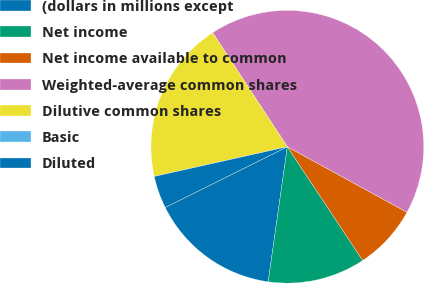Convert chart to OTSL. <chart><loc_0><loc_0><loc_500><loc_500><pie_chart><fcel>(dollars in millions except<fcel>Net income<fcel>Net income available to common<fcel>Weighted-average common shares<fcel>Dilutive common shares<fcel>Basic<fcel>Diluted<nl><fcel>15.41%<fcel>11.56%<fcel>7.71%<fcel>42.2%<fcel>19.27%<fcel>0.0%<fcel>3.85%<nl></chart> 